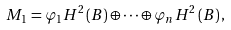<formula> <loc_0><loc_0><loc_500><loc_500>M _ { 1 } = \varphi _ { 1 } H ^ { 2 } \left ( B \right ) \oplus \cdots \oplus \varphi _ { n } H ^ { 2 } \left ( B \right ) ,</formula> 